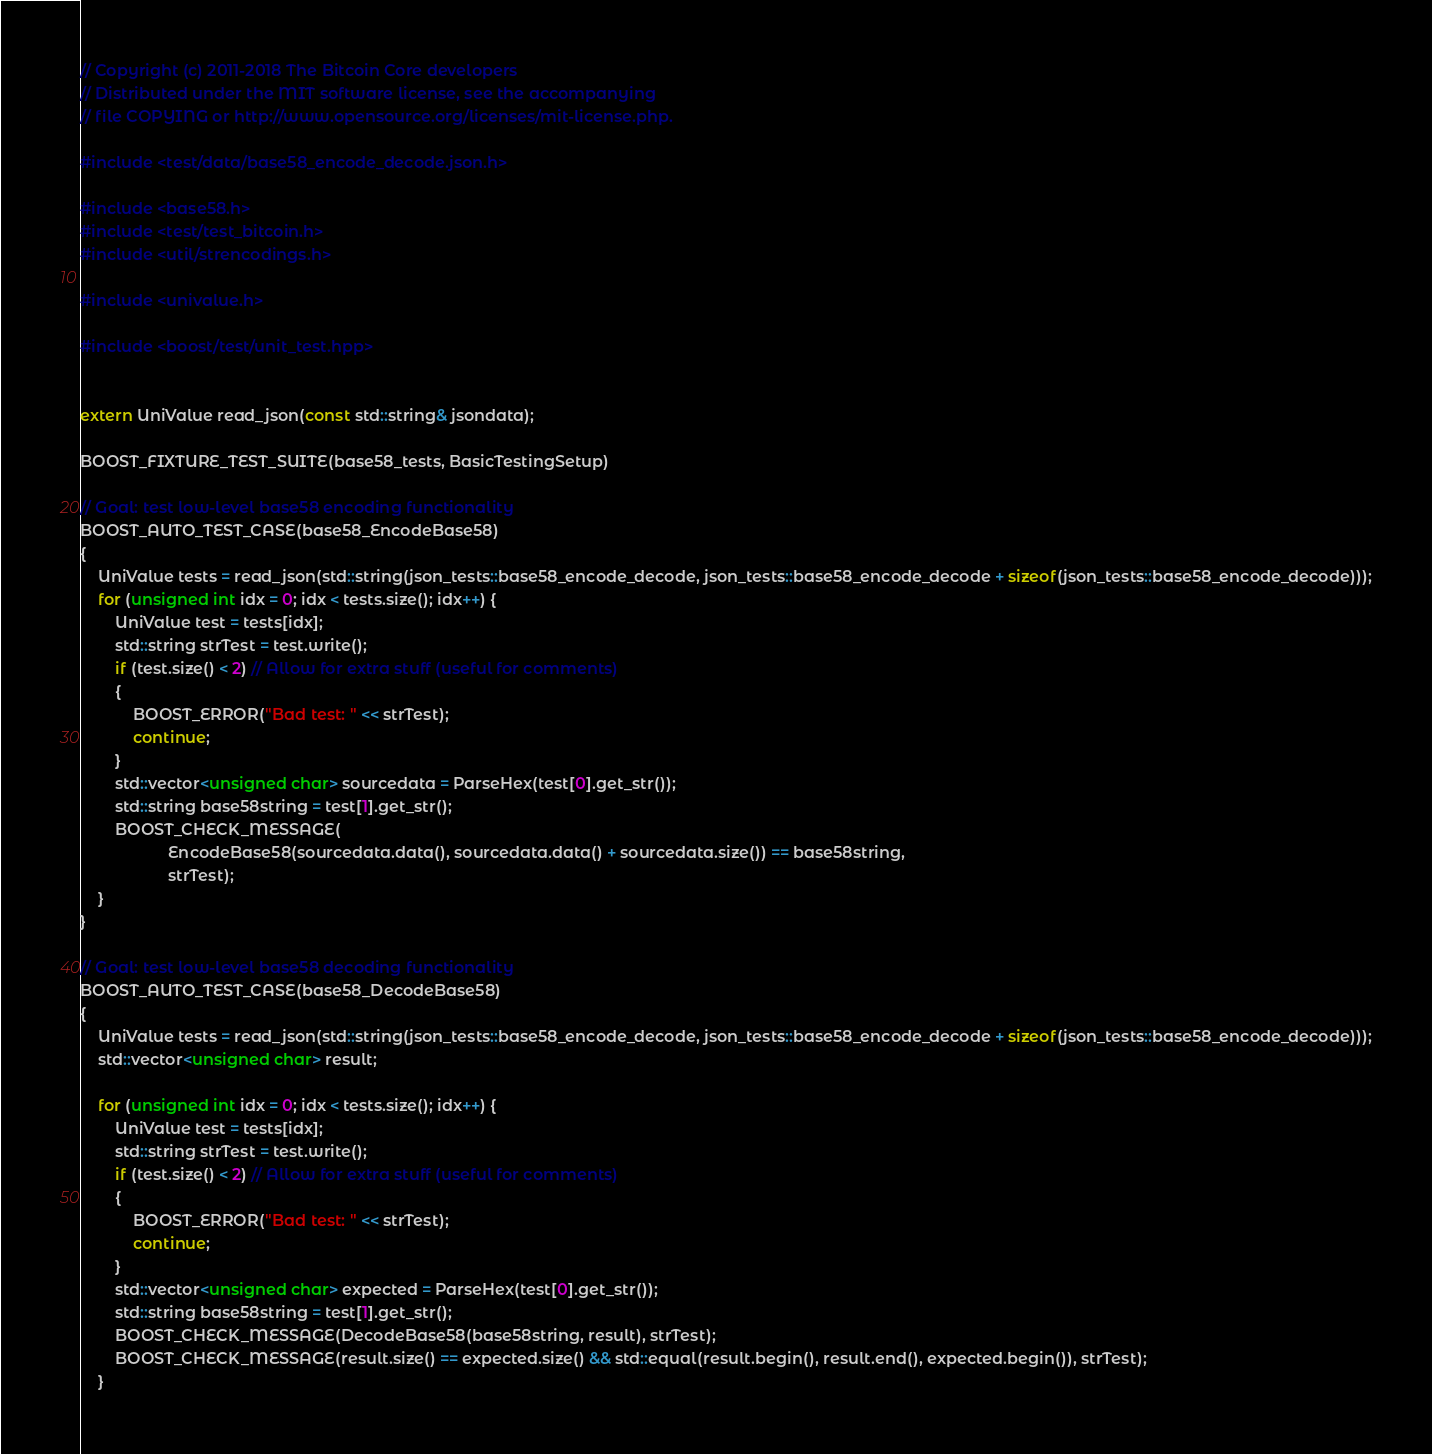<code> <loc_0><loc_0><loc_500><loc_500><_C++_>// Copyright (c) 2011-2018 The Bitcoin Core developers
// Distributed under the MIT software license, see the accompanying
// file COPYING or http://www.opensource.org/licenses/mit-license.php.

#include <test/data/base58_encode_decode.json.h>

#include <base58.h>
#include <test/test_bitcoin.h>
#include <util/strencodings.h>

#include <univalue.h>

#include <boost/test/unit_test.hpp>


extern UniValue read_json(const std::string& jsondata);

BOOST_FIXTURE_TEST_SUITE(base58_tests, BasicTestingSetup)

// Goal: test low-level base58 encoding functionality
BOOST_AUTO_TEST_CASE(base58_EncodeBase58)
{
    UniValue tests = read_json(std::string(json_tests::base58_encode_decode, json_tests::base58_encode_decode + sizeof(json_tests::base58_encode_decode)));
    for (unsigned int idx = 0; idx < tests.size(); idx++) {
        UniValue test = tests[idx];
        std::string strTest = test.write();
        if (test.size() < 2) // Allow for extra stuff (useful for comments)
        {
            BOOST_ERROR("Bad test: " << strTest);
            continue;
        }
        std::vector<unsigned char> sourcedata = ParseHex(test[0].get_str());
        std::string base58string = test[1].get_str();
        BOOST_CHECK_MESSAGE(
                    EncodeBase58(sourcedata.data(), sourcedata.data() + sourcedata.size()) == base58string,
                    strTest);
    }
}

// Goal: test low-level base58 decoding functionality
BOOST_AUTO_TEST_CASE(base58_DecodeBase58)
{
    UniValue tests = read_json(std::string(json_tests::base58_encode_decode, json_tests::base58_encode_decode + sizeof(json_tests::base58_encode_decode)));
    std::vector<unsigned char> result;

    for (unsigned int idx = 0; idx < tests.size(); idx++) {
        UniValue test = tests[idx];
        std::string strTest = test.write();
        if (test.size() < 2) // Allow for extra stuff (useful for comments)
        {
            BOOST_ERROR("Bad test: " << strTest);
            continue;
        }
        std::vector<unsigned char> expected = ParseHex(test[0].get_str());
        std::string base58string = test[1].get_str();
        BOOST_CHECK_MESSAGE(DecodeBase58(base58string, result), strTest);
        BOOST_CHECK_MESSAGE(result.size() == expected.size() && std::equal(result.begin(), result.end(), expected.begin()), strTest);
    }
</code> 